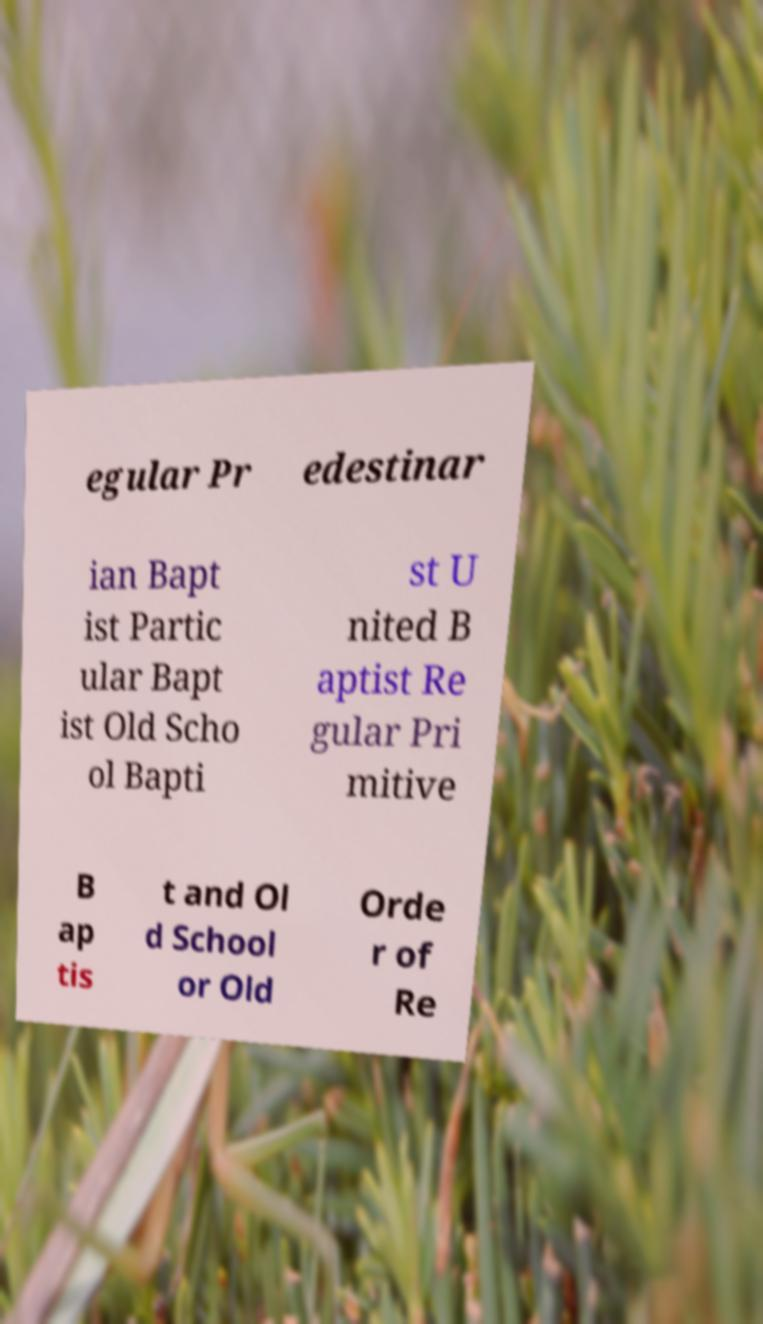What messages or text are displayed in this image? I need them in a readable, typed format. egular Pr edestinar ian Bapt ist Partic ular Bapt ist Old Scho ol Bapti st U nited B aptist Re gular Pri mitive B ap tis t and Ol d School or Old Orde r of Re 